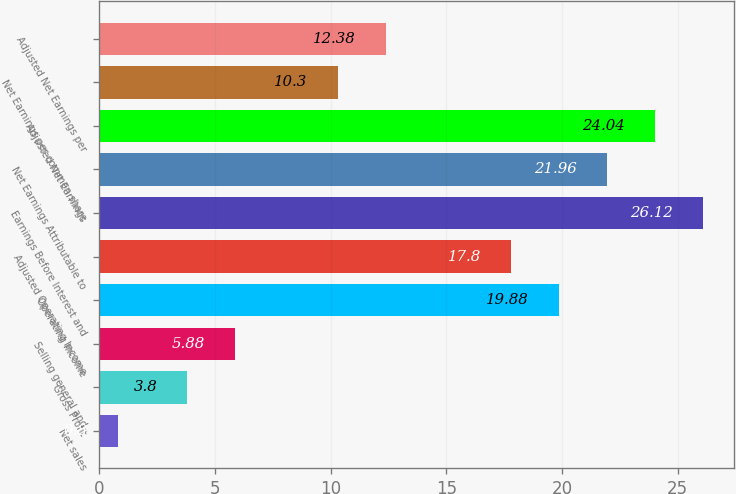Convert chart. <chart><loc_0><loc_0><loc_500><loc_500><bar_chart><fcel>Net sales<fcel>Gross Profit<fcel>Selling general and<fcel>Operating Income<fcel>Adjusted Operating Income<fcel>Earnings Before Interest and<fcel>Net Earnings Attributable to<fcel>Adjusted Net Earnings<fcel>Net Earnings per common share<fcel>Adjusted Net Earnings per<nl><fcel>0.8<fcel>3.8<fcel>5.88<fcel>19.88<fcel>17.8<fcel>26.12<fcel>21.96<fcel>24.04<fcel>10.3<fcel>12.38<nl></chart> 